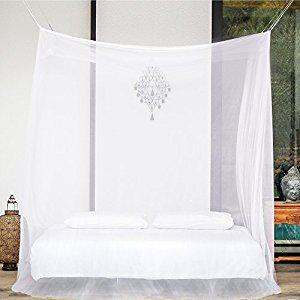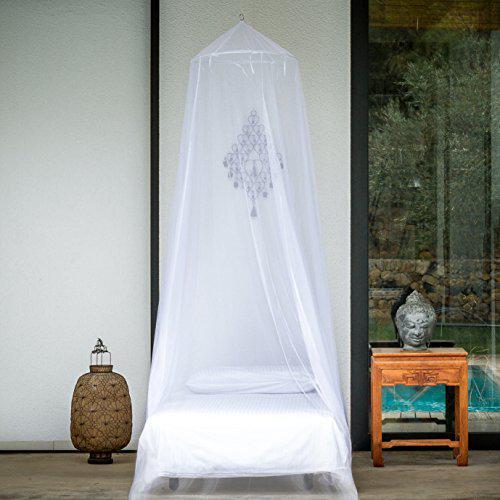The first image is the image on the left, the second image is the image on the right. For the images shown, is this caption "One of the beds has a wooden frame." true? Answer yes or no. No. 